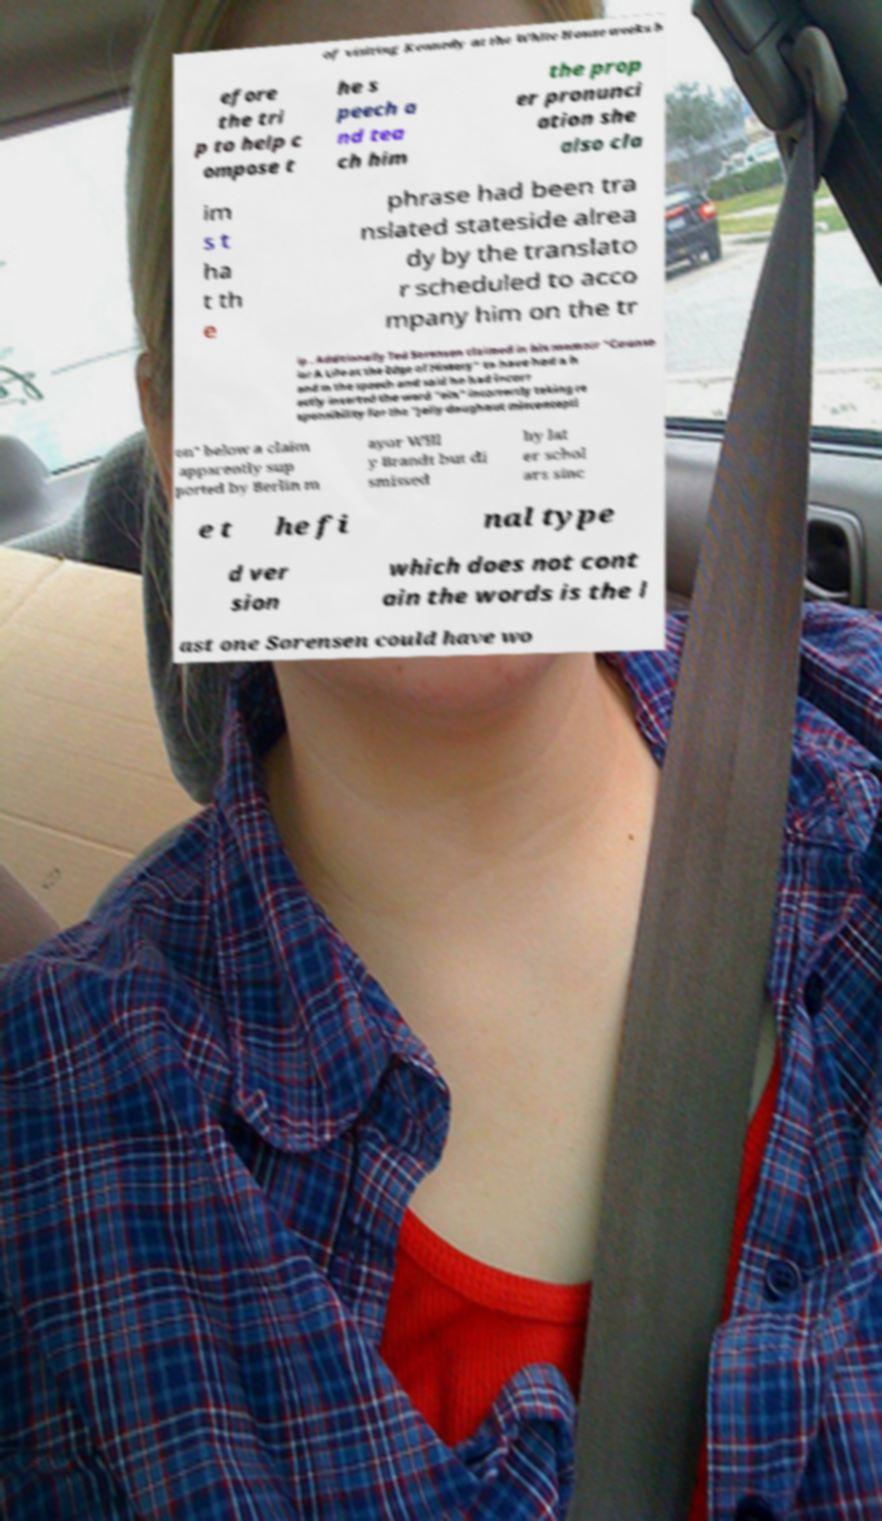What messages or text are displayed in this image? I need them in a readable, typed format. of visiting Kennedy at the White House weeks b efore the tri p to help c ompose t he s peech a nd tea ch him the prop er pronunci ation she also cla im s t ha t th e phrase had been tra nslated stateside alrea dy by the translato r scheduled to acco mpany him on the tr ip . Additionally Ted Sorensen claimed in his memoir "Counse lor A Life at the Edge of History" to have had a h and in the speech and said he had incorr ectly inserted the word "ein" incorrectly taking re sponsibility for the "jelly doughnut misconcepti on" below a claim apparently sup ported by Berlin m ayor Will y Brandt but di smissed by lat er schol ars sinc e t he fi nal type d ver sion which does not cont ain the words is the l ast one Sorensen could have wo 